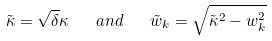<formula> <loc_0><loc_0><loc_500><loc_500>\tilde { \kappa } = \sqrt { \delta } \kappa \quad a n d \quad \tilde { w } _ { k } = \sqrt { \tilde { \kappa } ^ { 2 } - w _ { k } ^ { 2 } }</formula> 